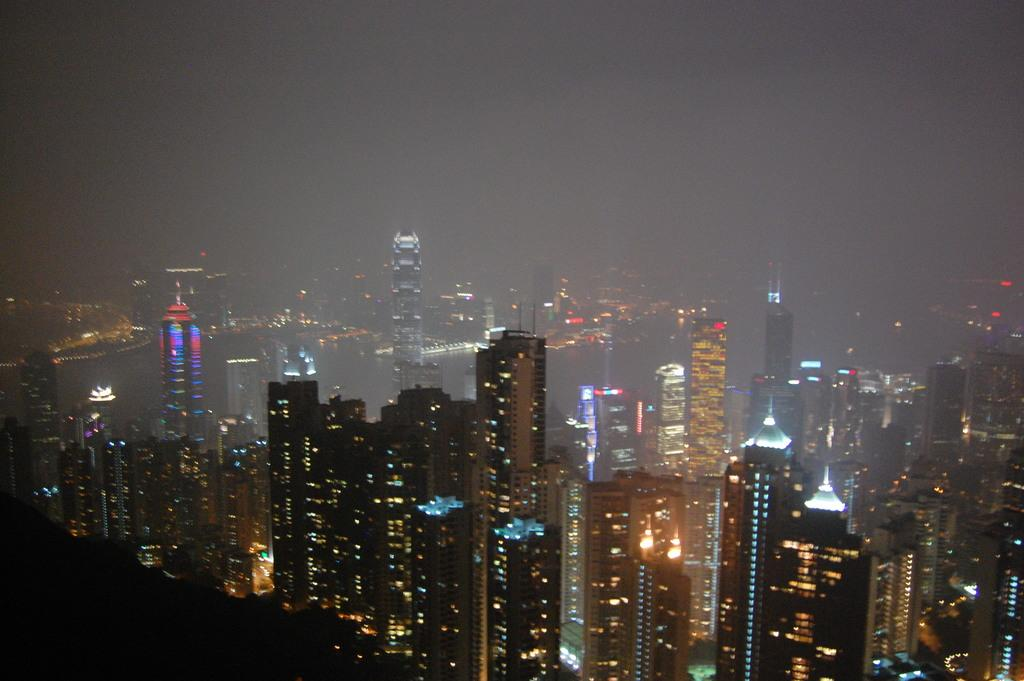What type of structures are visible in the image? There are buildings with lights in the image. What is visible at the top of the image? The sky is visible at the top of the image. Can you see any roots growing from the buildings in the image? There are no roots visible in the image; it features buildings with lights. What type of toothpaste is being used by the people in the image? There are no people or toothpaste present in the image. 